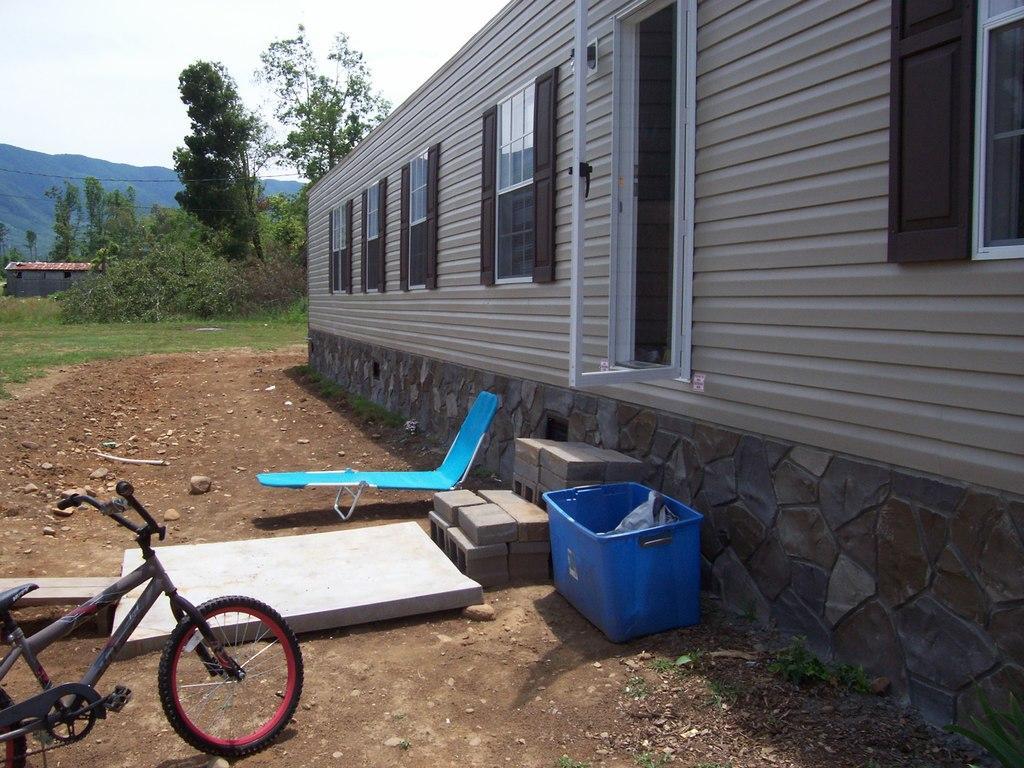How would you summarize this image in a sentence or two? This picture is clicked outside. On the left there is a bicycle parked on the ground and there are some objects placed on the ground. On the right we can see the house and a door and windows of the house. In the background there is a sky, hills, cables, trees and plants and the green grass. 